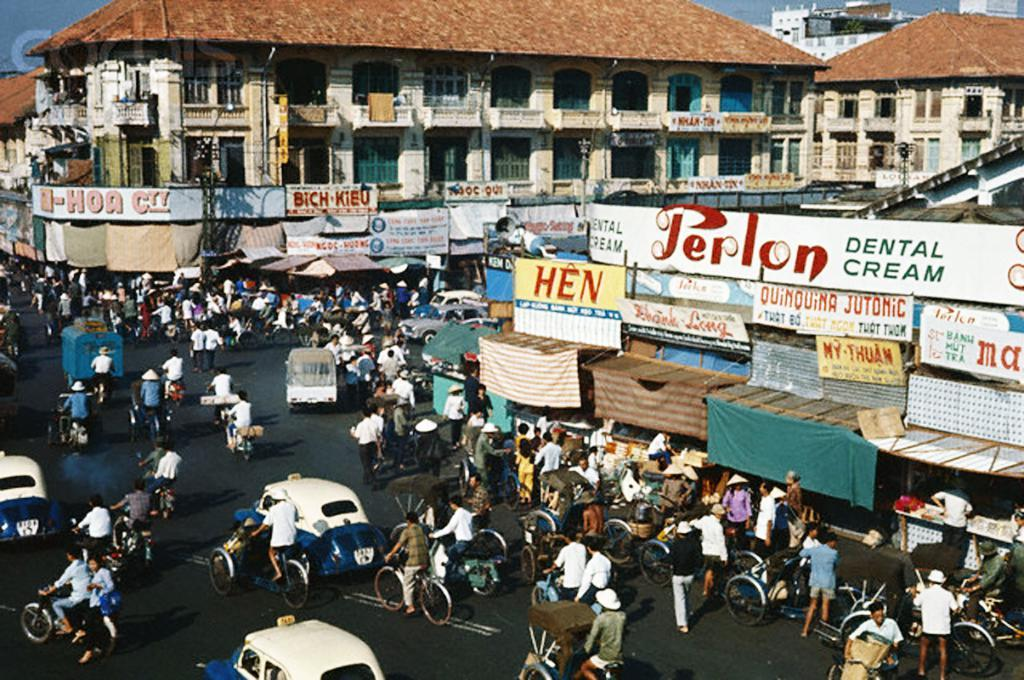How many people are in the image? There is a group of people in the image. What are some of the people doing in the image? Some people are walking, riding vehicles, and riding bicycles. What can be seen in the background of the image? There are hoardings and buildings in the background of the image. What type of pancake is being served at the horse race in the image? There is no horse race or pancake present in the image. What sense is being stimulated by the image? The image primarily stimulates the sense of sight, as it is a visual representation. 